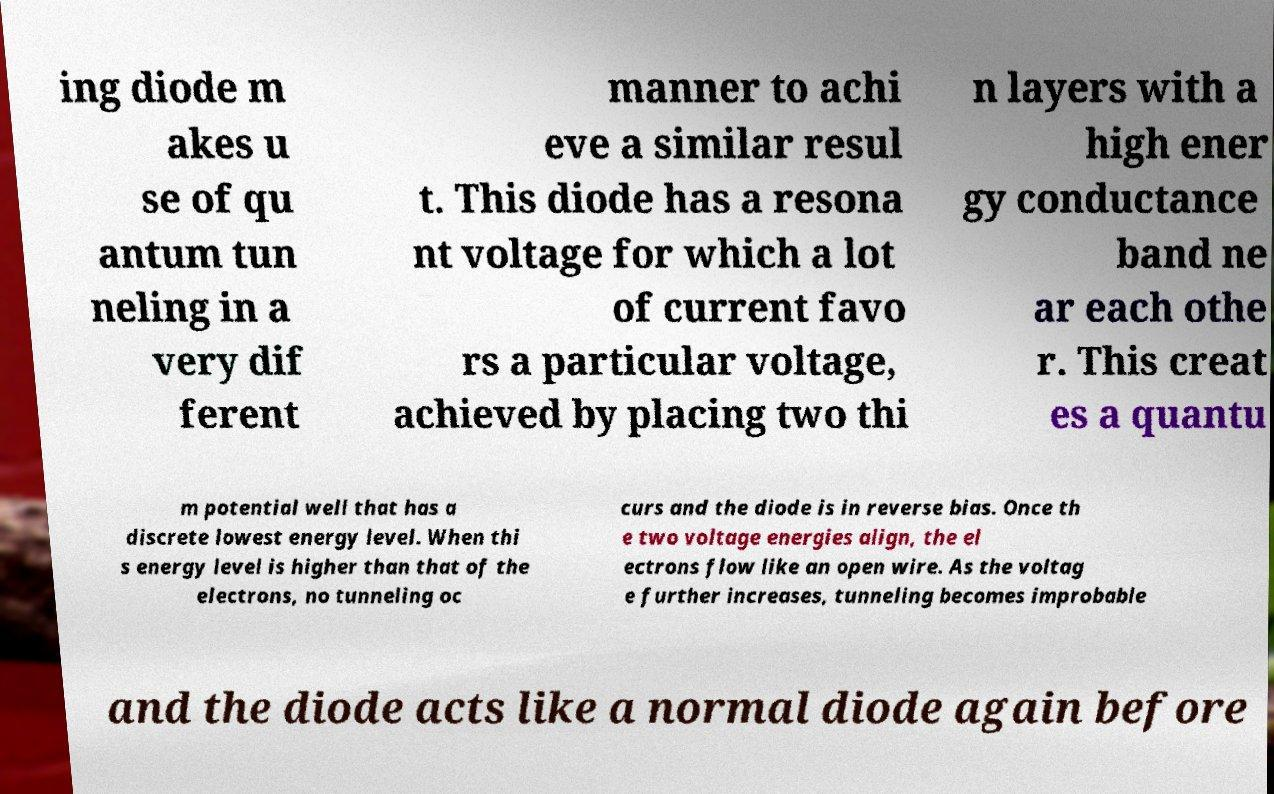Can you accurately transcribe the text from the provided image for me? ing diode m akes u se of qu antum tun neling in a very dif ferent manner to achi eve a similar resul t. This diode has a resona nt voltage for which a lot of current favo rs a particular voltage, achieved by placing two thi n layers with a high ener gy conductance band ne ar each othe r. This creat es a quantu m potential well that has a discrete lowest energy level. When thi s energy level is higher than that of the electrons, no tunneling oc curs and the diode is in reverse bias. Once th e two voltage energies align, the el ectrons flow like an open wire. As the voltag e further increases, tunneling becomes improbable and the diode acts like a normal diode again before 